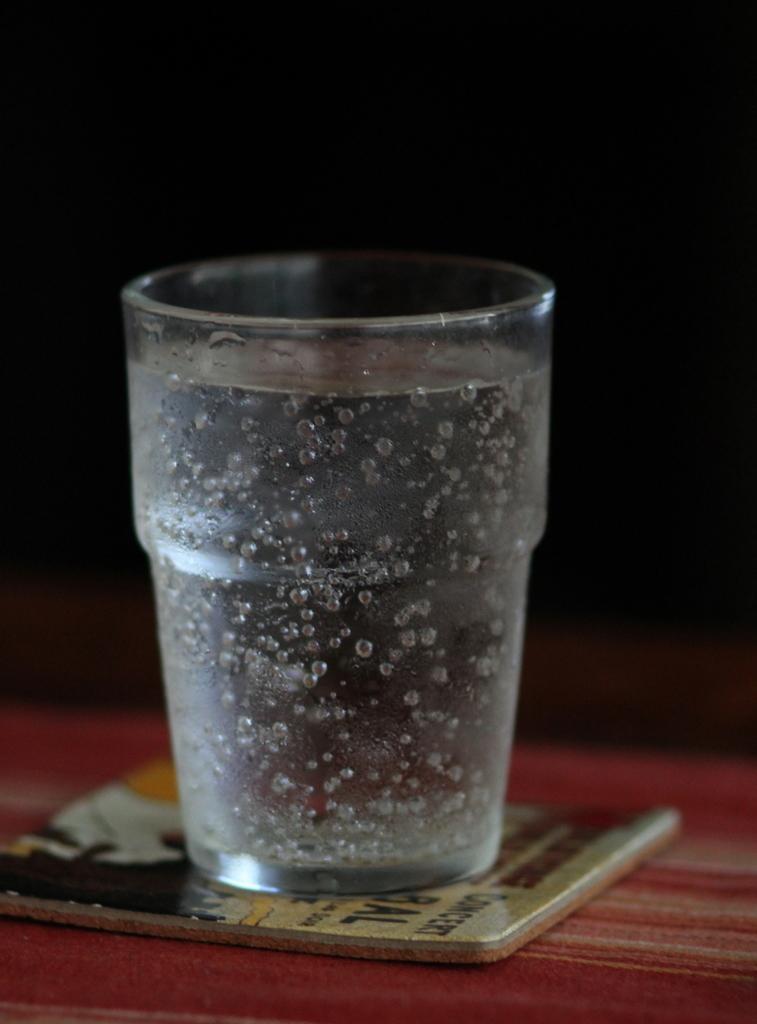Could you give a brief overview of what you see in this image? In the picture I can see a glass and an object on a red color surface. The background of the image is dark. 